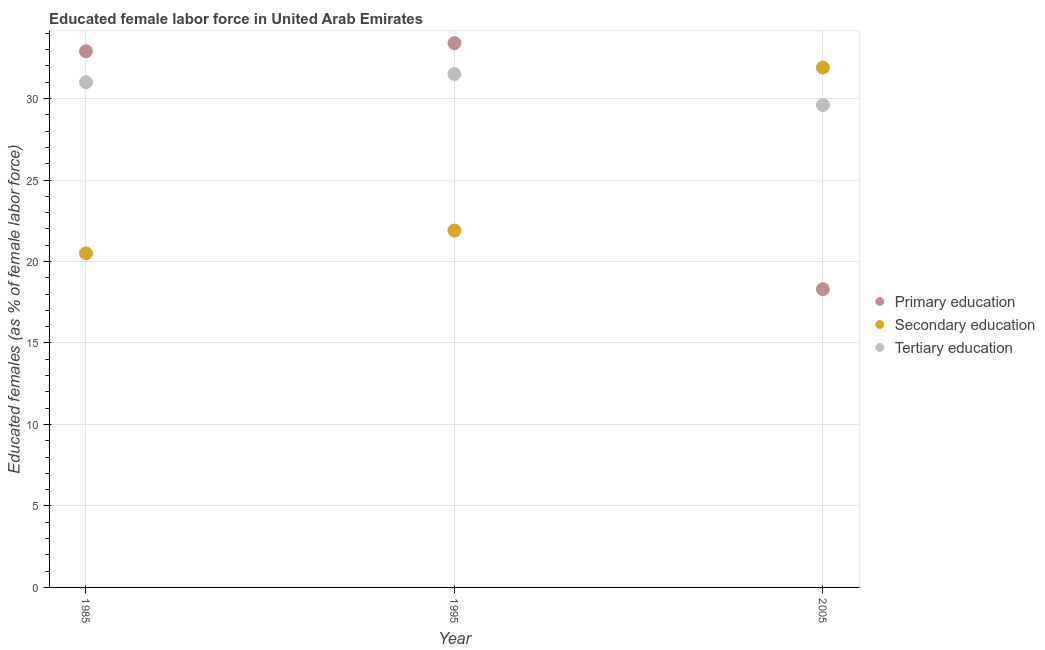What is the percentage of female labor force who received primary education in 1985?
Make the answer very short. 32.9. Across all years, what is the maximum percentage of female labor force who received tertiary education?
Make the answer very short. 31.5. Across all years, what is the minimum percentage of female labor force who received tertiary education?
Keep it short and to the point. 29.6. In which year was the percentage of female labor force who received primary education maximum?
Provide a succinct answer. 1995. In which year was the percentage of female labor force who received tertiary education minimum?
Offer a very short reply. 2005. What is the total percentage of female labor force who received tertiary education in the graph?
Your answer should be compact. 92.1. What is the difference between the percentage of female labor force who received tertiary education in 1995 and that in 2005?
Your answer should be compact. 1.9. What is the difference between the percentage of female labor force who received primary education in 1985 and the percentage of female labor force who received secondary education in 2005?
Provide a succinct answer. 1. What is the average percentage of female labor force who received primary education per year?
Offer a terse response. 28.2. In the year 1995, what is the difference between the percentage of female labor force who received primary education and percentage of female labor force who received secondary education?
Your answer should be very brief. 11.5. In how many years, is the percentage of female labor force who received tertiary education greater than 15 %?
Offer a terse response. 3. What is the ratio of the percentage of female labor force who received primary education in 1985 to that in 2005?
Your response must be concise. 1.8. Is the percentage of female labor force who received tertiary education in 1985 less than that in 2005?
Make the answer very short. No. Is the difference between the percentage of female labor force who received primary education in 1985 and 1995 greater than the difference between the percentage of female labor force who received secondary education in 1985 and 1995?
Give a very brief answer. Yes. What is the difference between the highest and the second highest percentage of female labor force who received primary education?
Provide a short and direct response. 0.5. What is the difference between the highest and the lowest percentage of female labor force who received primary education?
Your answer should be compact. 15.1. Is it the case that in every year, the sum of the percentage of female labor force who received primary education and percentage of female labor force who received secondary education is greater than the percentage of female labor force who received tertiary education?
Make the answer very short. Yes. Does the percentage of female labor force who received secondary education monotonically increase over the years?
Keep it short and to the point. Yes. Is the percentage of female labor force who received primary education strictly greater than the percentage of female labor force who received tertiary education over the years?
Your response must be concise. No. Are the values on the major ticks of Y-axis written in scientific E-notation?
Provide a short and direct response. No. How many legend labels are there?
Give a very brief answer. 3. What is the title of the graph?
Keep it short and to the point. Educated female labor force in United Arab Emirates. What is the label or title of the X-axis?
Your answer should be very brief. Year. What is the label or title of the Y-axis?
Your answer should be compact. Educated females (as % of female labor force). What is the Educated females (as % of female labor force) of Primary education in 1985?
Keep it short and to the point. 32.9. What is the Educated females (as % of female labor force) in Secondary education in 1985?
Give a very brief answer. 20.5. What is the Educated females (as % of female labor force) in Tertiary education in 1985?
Make the answer very short. 31. What is the Educated females (as % of female labor force) of Primary education in 1995?
Offer a very short reply. 33.4. What is the Educated females (as % of female labor force) of Secondary education in 1995?
Your response must be concise. 21.9. What is the Educated females (as % of female labor force) of Tertiary education in 1995?
Make the answer very short. 31.5. What is the Educated females (as % of female labor force) in Primary education in 2005?
Keep it short and to the point. 18.3. What is the Educated females (as % of female labor force) in Secondary education in 2005?
Provide a succinct answer. 31.9. What is the Educated females (as % of female labor force) in Tertiary education in 2005?
Ensure brevity in your answer.  29.6. Across all years, what is the maximum Educated females (as % of female labor force) in Primary education?
Provide a succinct answer. 33.4. Across all years, what is the maximum Educated females (as % of female labor force) in Secondary education?
Offer a terse response. 31.9. Across all years, what is the maximum Educated females (as % of female labor force) of Tertiary education?
Ensure brevity in your answer.  31.5. Across all years, what is the minimum Educated females (as % of female labor force) of Primary education?
Your response must be concise. 18.3. Across all years, what is the minimum Educated females (as % of female labor force) in Secondary education?
Provide a succinct answer. 20.5. Across all years, what is the minimum Educated females (as % of female labor force) of Tertiary education?
Keep it short and to the point. 29.6. What is the total Educated females (as % of female labor force) in Primary education in the graph?
Ensure brevity in your answer.  84.6. What is the total Educated females (as % of female labor force) of Secondary education in the graph?
Ensure brevity in your answer.  74.3. What is the total Educated females (as % of female labor force) in Tertiary education in the graph?
Your answer should be compact. 92.1. What is the difference between the Educated females (as % of female labor force) in Tertiary education in 1985 and that in 1995?
Provide a short and direct response. -0.5. What is the difference between the Educated females (as % of female labor force) of Secondary education in 1985 and the Educated females (as % of female labor force) of Tertiary education in 2005?
Your response must be concise. -9.1. What is the difference between the Educated females (as % of female labor force) in Primary education in 1995 and the Educated females (as % of female labor force) in Secondary education in 2005?
Your answer should be very brief. 1.5. What is the average Educated females (as % of female labor force) in Primary education per year?
Your answer should be very brief. 28.2. What is the average Educated females (as % of female labor force) in Secondary education per year?
Your answer should be very brief. 24.77. What is the average Educated females (as % of female labor force) in Tertiary education per year?
Keep it short and to the point. 30.7. In the year 1985, what is the difference between the Educated females (as % of female labor force) of Primary education and Educated females (as % of female labor force) of Secondary education?
Give a very brief answer. 12.4. In the year 1985, what is the difference between the Educated females (as % of female labor force) of Secondary education and Educated females (as % of female labor force) of Tertiary education?
Provide a short and direct response. -10.5. In the year 1995, what is the difference between the Educated females (as % of female labor force) in Primary education and Educated females (as % of female labor force) in Secondary education?
Provide a succinct answer. 11.5. In the year 1995, what is the difference between the Educated females (as % of female labor force) in Secondary education and Educated females (as % of female labor force) in Tertiary education?
Ensure brevity in your answer.  -9.6. In the year 2005, what is the difference between the Educated females (as % of female labor force) in Primary education and Educated females (as % of female labor force) in Secondary education?
Keep it short and to the point. -13.6. In the year 2005, what is the difference between the Educated females (as % of female labor force) of Secondary education and Educated females (as % of female labor force) of Tertiary education?
Provide a short and direct response. 2.3. What is the ratio of the Educated females (as % of female labor force) of Primary education in 1985 to that in 1995?
Offer a terse response. 0.98. What is the ratio of the Educated females (as % of female labor force) of Secondary education in 1985 to that in 1995?
Make the answer very short. 0.94. What is the ratio of the Educated females (as % of female labor force) in Tertiary education in 1985 to that in 1995?
Provide a short and direct response. 0.98. What is the ratio of the Educated females (as % of female labor force) of Primary education in 1985 to that in 2005?
Your answer should be very brief. 1.8. What is the ratio of the Educated females (as % of female labor force) in Secondary education in 1985 to that in 2005?
Ensure brevity in your answer.  0.64. What is the ratio of the Educated females (as % of female labor force) of Tertiary education in 1985 to that in 2005?
Give a very brief answer. 1.05. What is the ratio of the Educated females (as % of female labor force) in Primary education in 1995 to that in 2005?
Keep it short and to the point. 1.83. What is the ratio of the Educated females (as % of female labor force) of Secondary education in 1995 to that in 2005?
Offer a very short reply. 0.69. What is the ratio of the Educated females (as % of female labor force) of Tertiary education in 1995 to that in 2005?
Provide a short and direct response. 1.06. What is the difference between the highest and the second highest Educated females (as % of female labor force) in Tertiary education?
Offer a terse response. 0.5. What is the difference between the highest and the lowest Educated females (as % of female labor force) of Secondary education?
Your answer should be compact. 11.4. What is the difference between the highest and the lowest Educated females (as % of female labor force) of Tertiary education?
Provide a short and direct response. 1.9. 